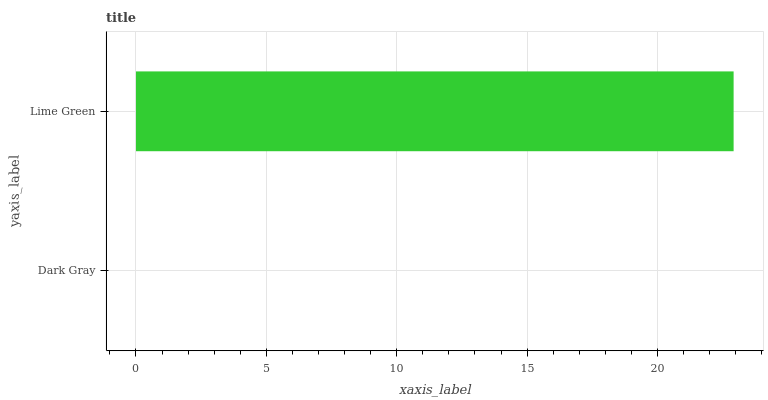Is Dark Gray the minimum?
Answer yes or no. Yes. Is Lime Green the maximum?
Answer yes or no. Yes. Is Lime Green the minimum?
Answer yes or no. No. Is Lime Green greater than Dark Gray?
Answer yes or no. Yes. Is Dark Gray less than Lime Green?
Answer yes or no. Yes. Is Dark Gray greater than Lime Green?
Answer yes or no. No. Is Lime Green less than Dark Gray?
Answer yes or no. No. Is Lime Green the high median?
Answer yes or no. Yes. Is Dark Gray the low median?
Answer yes or no. Yes. Is Dark Gray the high median?
Answer yes or no. No. Is Lime Green the low median?
Answer yes or no. No. 